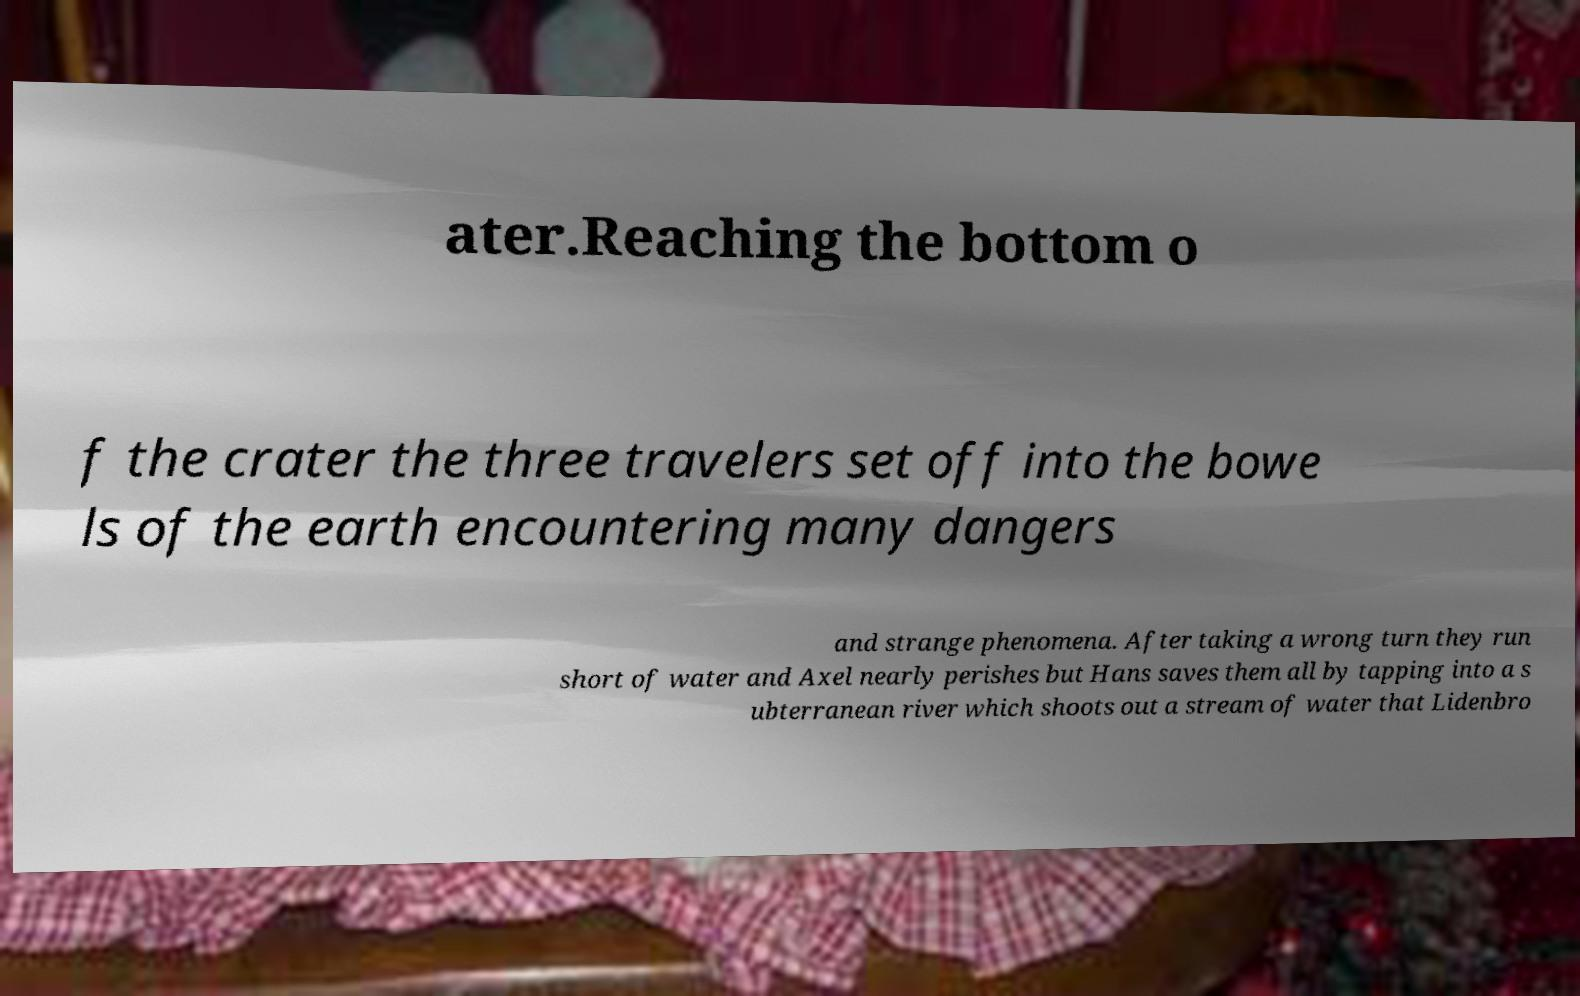Please read and relay the text visible in this image. What does it say? ater.Reaching the bottom o f the crater the three travelers set off into the bowe ls of the earth encountering many dangers and strange phenomena. After taking a wrong turn they run short of water and Axel nearly perishes but Hans saves them all by tapping into a s ubterranean river which shoots out a stream of water that Lidenbro 